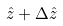<formula> <loc_0><loc_0><loc_500><loc_500>\hat { z } + \Delta \hat { z }</formula> 